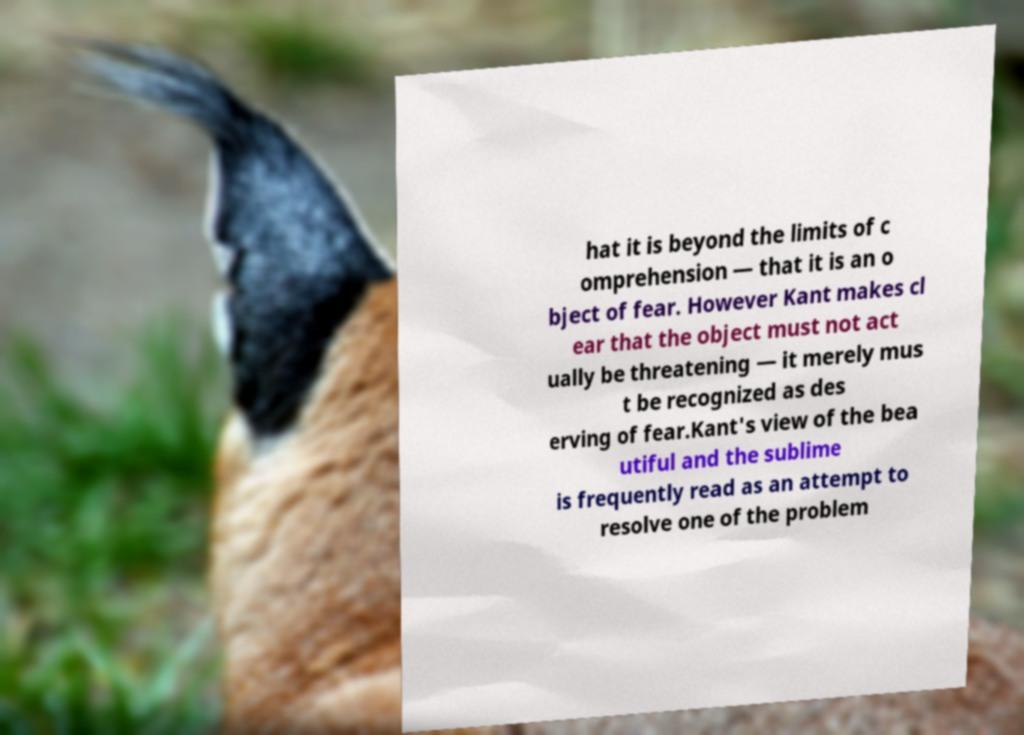Could you extract and type out the text from this image? hat it is beyond the limits of c omprehension — that it is an o bject of fear. However Kant makes cl ear that the object must not act ually be threatening — it merely mus t be recognized as des erving of fear.Kant's view of the bea utiful and the sublime is frequently read as an attempt to resolve one of the problem 